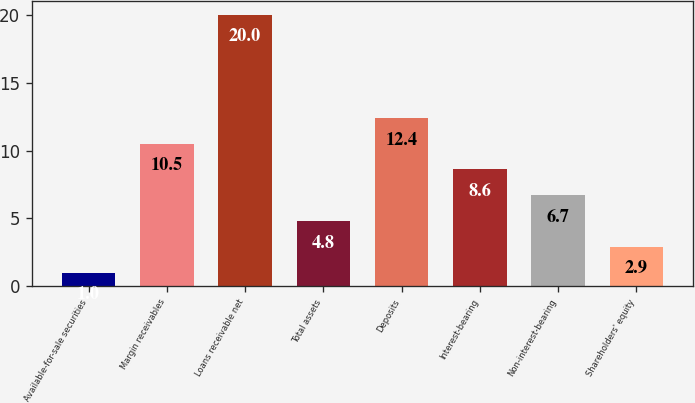Convert chart. <chart><loc_0><loc_0><loc_500><loc_500><bar_chart><fcel>Available-for-sale securities<fcel>Margin receivables<fcel>Loans receivable net<fcel>Total assets<fcel>Deposits<fcel>Interest-bearing<fcel>Non-interest-bearing<fcel>Shareholders' equity<nl><fcel>1<fcel>10.5<fcel>20<fcel>4.8<fcel>12.4<fcel>8.6<fcel>6.7<fcel>2.9<nl></chart> 